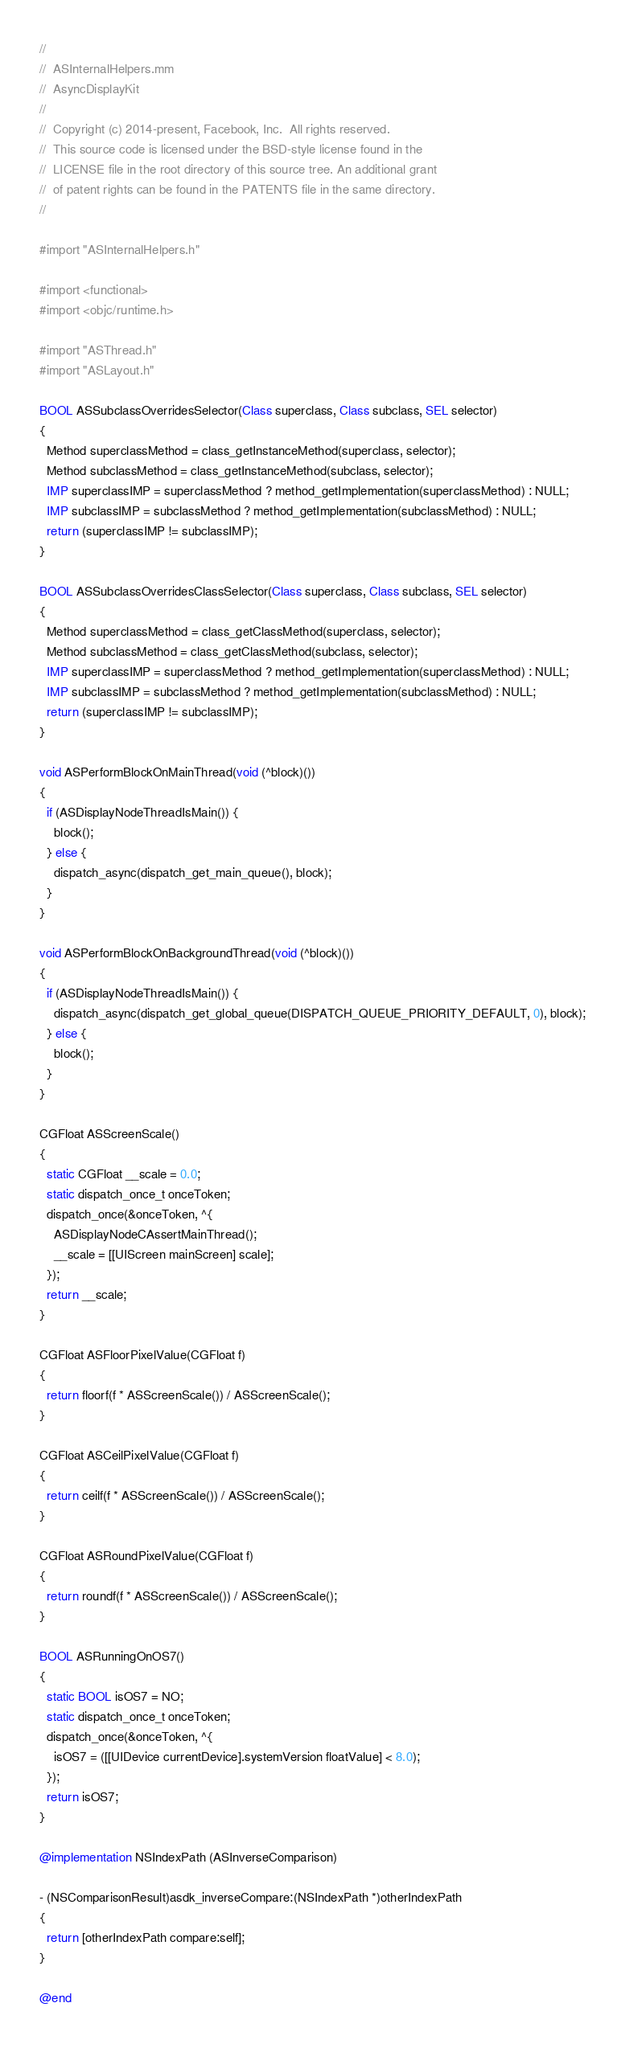<code> <loc_0><loc_0><loc_500><loc_500><_ObjectiveC_>//
//  ASInternalHelpers.mm
//  AsyncDisplayKit
//
//  Copyright (c) 2014-present, Facebook, Inc.  All rights reserved.
//  This source code is licensed under the BSD-style license found in the
//  LICENSE file in the root directory of this source tree. An additional grant
//  of patent rights can be found in the PATENTS file in the same directory.
//

#import "ASInternalHelpers.h"

#import <functional>
#import <objc/runtime.h>

#import "ASThread.h"
#import "ASLayout.h"

BOOL ASSubclassOverridesSelector(Class superclass, Class subclass, SEL selector)
{
  Method superclassMethod = class_getInstanceMethod(superclass, selector);
  Method subclassMethod = class_getInstanceMethod(subclass, selector);
  IMP superclassIMP = superclassMethod ? method_getImplementation(superclassMethod) : NULL;
  IMP subclassIMP = subclassMethod ? method_getImplementation(subclassMethod) : NULL;
  return (superclassIMP != subclassIMP);
}

BOOL ASSubclassOverridesClassSelector(Class superclass, Class subclass, SEL selector)
{
  Method superclassMethod = class_getClassMethod(superclass, selector);
  Method subclassMethod = class_getClassMethod(subclass, selector);
  IMP superclassIMP = superclassMethod ? method_getImplementation(superclassMethod) : NULL;
  IMP subclassIMP = subclassMethod ? method_getImplementation(subclassMethod) : NULL;
  return (superclassIMP != subclassIMP);
}

void ASPerformBlockOnMainThread(void (^block)())
{
  if (ASDisplayNodeThreadIsMain()) {
    block();
  } else {
    dispatch_async(dispatch_get_main_queue(), block);
  }
}

void ASPerformBlockOnBackgroundThread(void (^block)())
{
  if (ASDisplayNodeThreadIsMain()) {
    dispatch_async(dispatch_get_global_queue(DISPATCH_QUEUE_PRIORITY_DEFAULT, 0), block);
  } else {
    block();
  }
}

CGFloat ASScreenScale()
{
  static CGFloat __scale = 0.0;
  static dispatch_once_t onceToken;
  dispatch_once(&onceToken, ^{
    ASDisplayNodeCAssertMainThread();
    __scale = [[UIScreen mainScreen] scale];
  });
  return __scale;
}

CGFloat ASFloorPixelValue(CGFloat f)
{
  return floorf(f * ASScreenScale()) / ASScreenScale();
}

CGFloat ASCeilPixelValue(CGFloat f)
{
  return ceilf(f * ASScreenScale()) / ASScreenScale();
}

CGFloat ASRoundPixelValue(CGFloat f)
{
  return roundf(f * ASScreenScale()) / ASScreenScale();
}

BOOL ASRunningOnOS7()
{
  static BOOL isOS7 = NO;
  static dispatch_once_t onceToken;
  dispatch_once(&onceToken, ^{
    isOS7 = ([[UIDevice currentDevice].systemVersion floatValue] < 8.0);
  });
  return isOS7;
}

@implementation NSIndexPath (ASInverseComparison)

- (NSComparisonResult)asdk_inverseCompare:(NSIndexPath *)otherIndexPath
{
  return [otherIndexPath compare:self];
}

@end
</code> 